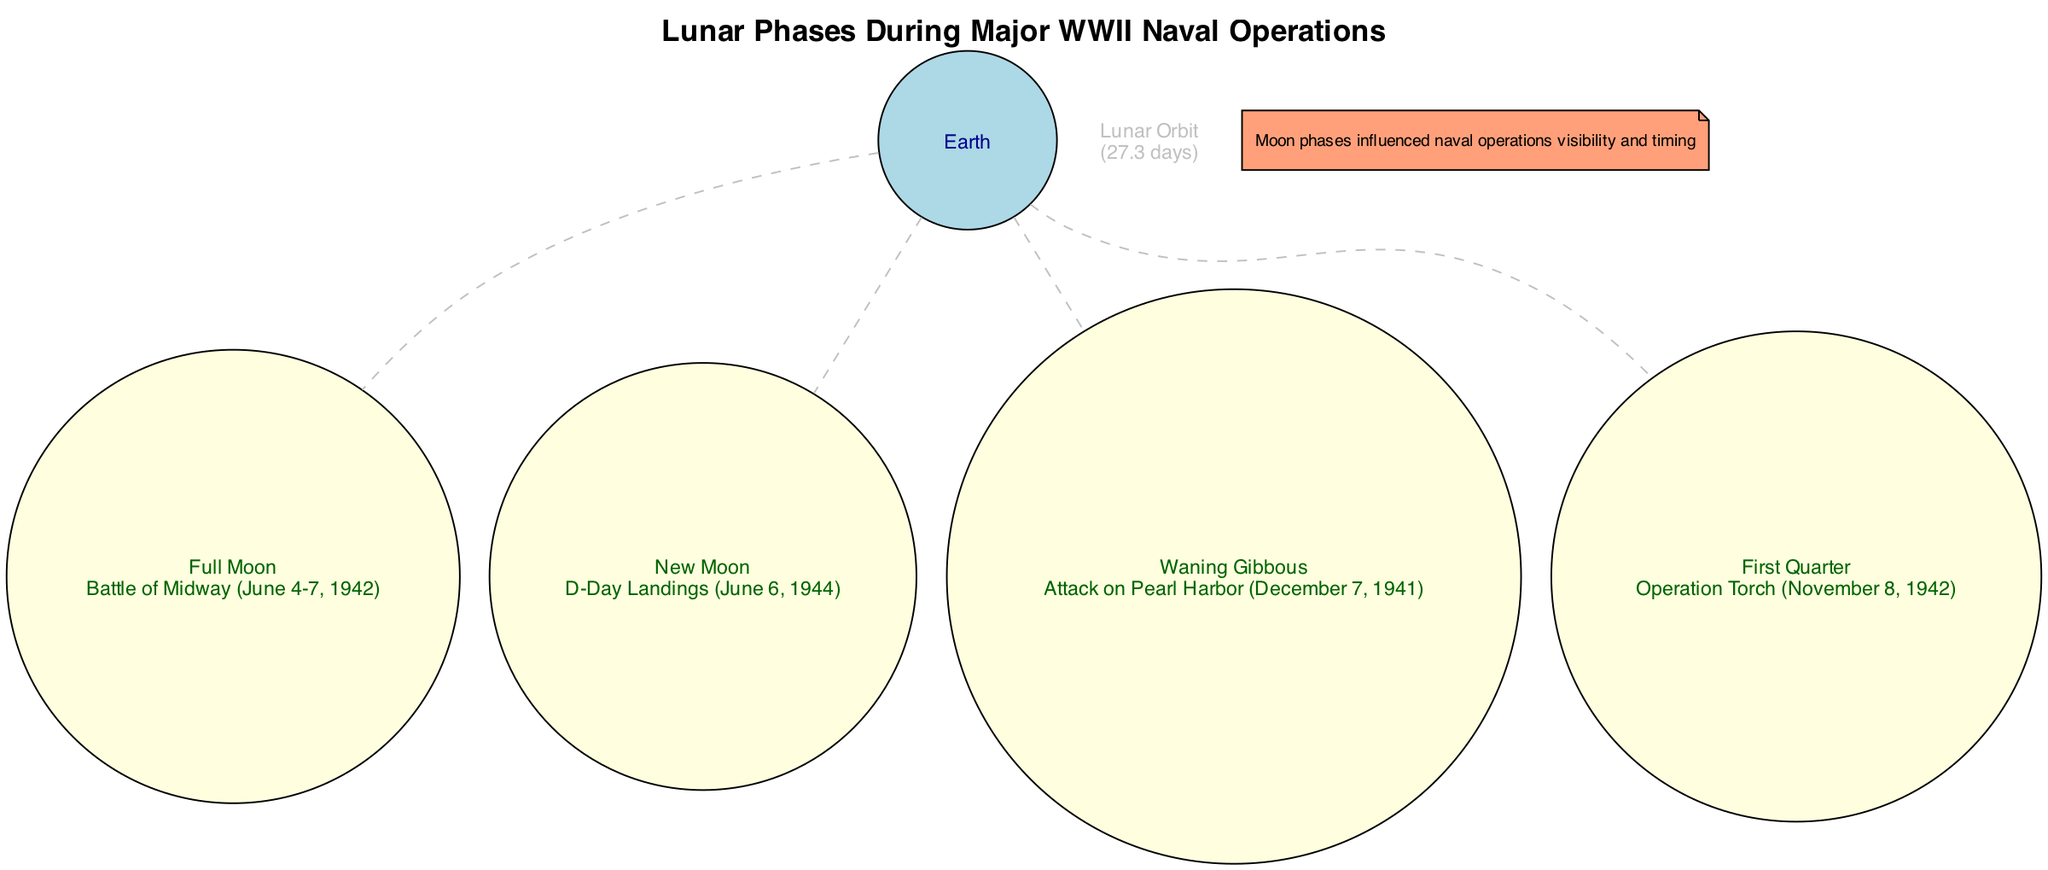What is the moon phase during the Battle of Midway? The diagram states that the Battle of Midway occurred during a Full Moon, which is explicitly mentioned next to that specific moon phase.
Answer: Full Moon Which operation took place during a New Moon? The D-Day Landings are directly associated with a New Moon, as indicated in the description under the New Moon phase in the diagram.
Answer: D-Day Landings How many moon phases are depicted in the diagram? There are four distinct moon phases displayed: Full Moon, New Moon, Waning Gibbous, and First Quarter. Counting these phases gives us a total of four.
Answer: 4 What lunar phase is associated with the Attack on Pearl Harbor? The Attack on Pearl Harbor is indicated in the description next to the Waning Gibbous phase. Thus, this is the lunar phase relevant to the operation.
Answer: Waning Gibbous What celestial body is at the center of the diagram? The diagram specifically identifies Earth as being at the center, providing context for the lunar phases surrounding it.
Answer: Earth What is the described duration of the lunar orbit? The diagram notes the lunar orbit's duration as 27.3 days. This information is clearly listed under the Lunar Orbit node.
Answer: 27.3 days During which operation does the First Quarter moon phase appear? The First Quarter moon phase corresponds with Operation Torch, as stated in the description adjacent to that specific moon phase.
Answer: Operation Torch How does the diagram suggest moon phases influenced naval operations? A note within the diagram explicitly states that "Moon phases influenced naval operations visibility and timing," indicating the practical implications of the lunar phases on military strategies.
Answer: Moon phases influenced naval operations visibility and timing Which moon phase is connected to the D-Day Landings? The D-Day Landings are directly linked to the New Moon phase, as noted in the description associated with that phase in the diagram.
Answer: New Moon 